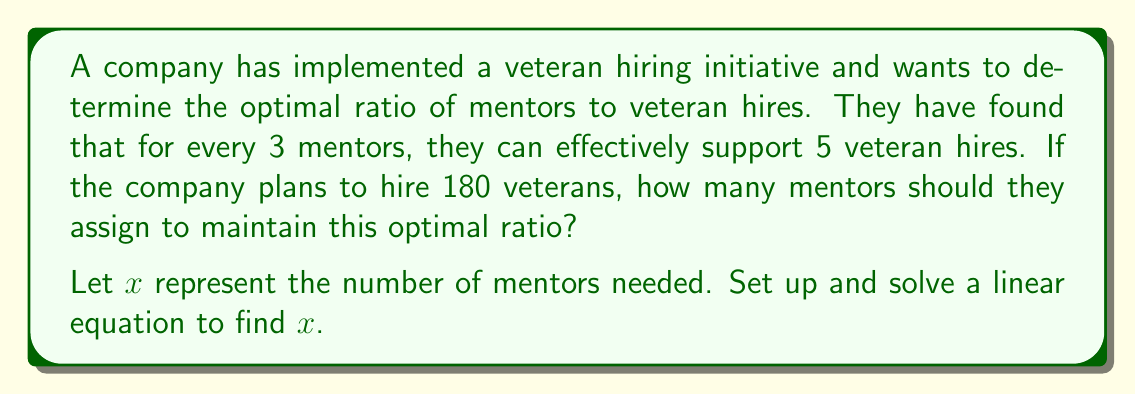What is the answer to this math problem? Let's approach this step-by-step:

1) We know that 3 mentors can support 5 veteran hires. This gives us our ratio:
   
   $\frac{3 \text{ mentors}}{5 \text{ veteran hires}}$

2) We need to set up an equation where this ratio is equal to the ratio of mentors ($x$) to the total number of veteran hires (180):

   $\frac{x}{180} = \frac{3}{5}$

3) To solve for $x$, we can cross-multiply:

   $5x = 3 \cdot 180$

4) Simplify the right side:

   $5x = 540$

5) Divide both sides by 5:

   $x = \frac{540}{5} = 108$

Therefore, the company should assign 108 mentors to maintain the optimal ratio for 180 veteran hires.
Answer: 108 mentors 